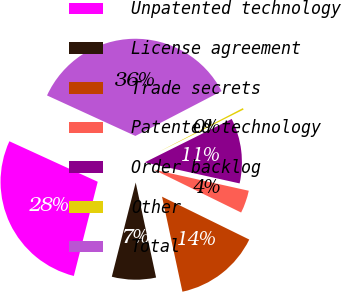<chart> <loc_0><loc_0><loc_500><loc_500><pie_chart><fcel>Unpatented technology<fcel>License agreement<fcel>Trade secrets<fcel>Patented technology<fcel>Order backlog<fcel>Other<fcel>Total<nl><fcel>27.89%<fcel>7.32%<fcel>14.37%<fcel>3.79%<fcel>10.84%<fcel>0.27%<fcel>35.53%<nl></chart> 